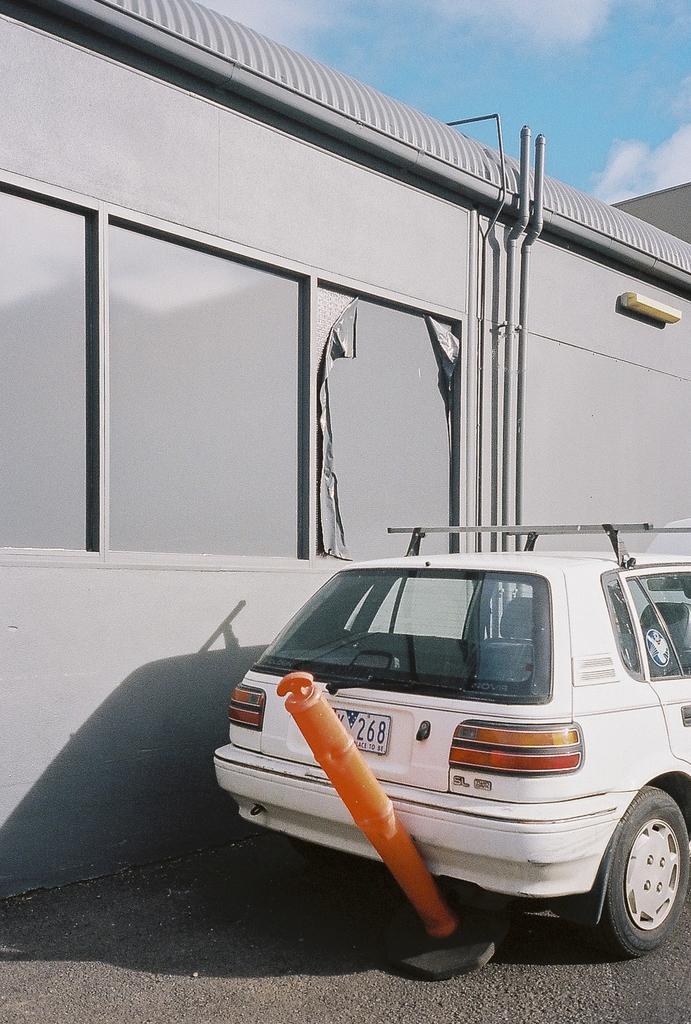Please provide a concise description of this image. In this image we can see a vehicle and an object on the road. In the background we can see wall, pipes, and other objects. At the top of the image we can see sky with clouds. 